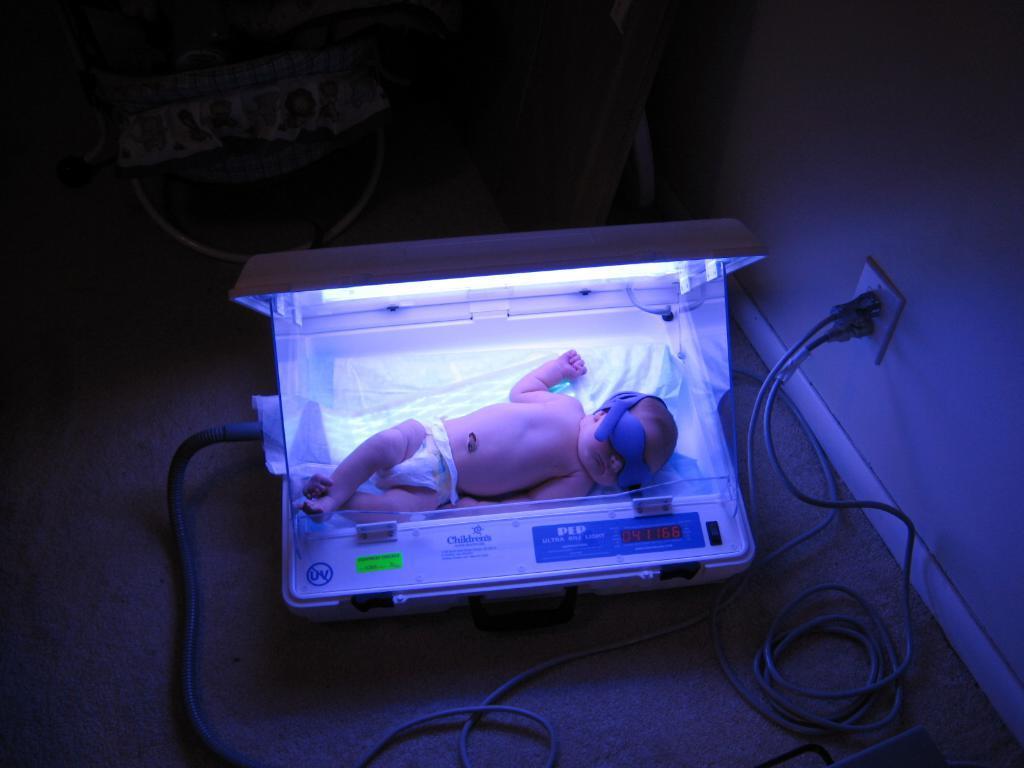Can you describe this image briefly? As we can see in the image there is a wall, switch board, wires, child and an electrical equipment. 